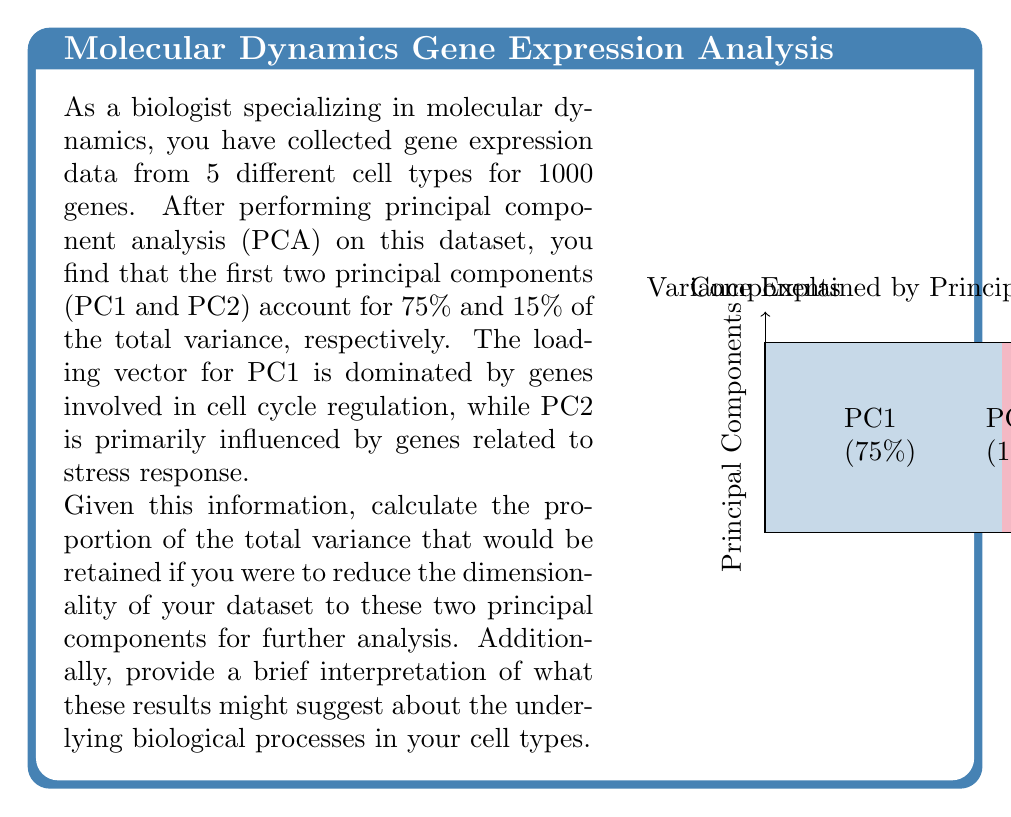Can you answer this question? To solve this problem, we need to follow these steps:

1) Understand the concept of variance explained in PCA:
   In PCA, each principal component accounts for a certain proportion of the total variance in the dataset. The sum of the variance explained by all principal components equals 100% of the total variance.

2) Identify the variance explained by PC1 and PC2:
   - PC1 accounts for 75% of the total variance
   - PC2 accounts for 15% of the total variance

3) Calculate the total variance retained by PC1 and PC2:
   $$\text{Total variance retained} = \text{Variance explained by PC1} + \text{Variance explained by PC2}$$
   $$\text{Total variance retained} = 75\% + 15\% = 90\%$$

4) Convert the percentage to a proportion:
   $$\text{Proportion} = \frac{\text{Percentage}}{100} = \frac{90}{100} = 0.90$$

5) Interpret the results:
   - Reducing the dimensionality to the first two principal components would retain 90% of the total variance in the dataset.
   - PC1, accounting for 75% of the variance, is dominated by cell cycle regulation genes. This suggests that the main source of variation among the cell types is related to differences in their cell cycle states or proliferation rates.
   - PC2, explaining 15% of the variance, is influenced by stress response genes. This indicates that the second most important source of variation among the cell types is their response to stress factors.
   - Together, these two components capture the majority of the biological variation in the dataset, allowing for a significant reduction in dimensionality while retaining most of the relevant information for further analysis.
Answer: 0.90; PC1 (cell cycle) and PC2 (stress response) capture 90% of variance, indicating these are primary biological processes differentiating the cell types. 